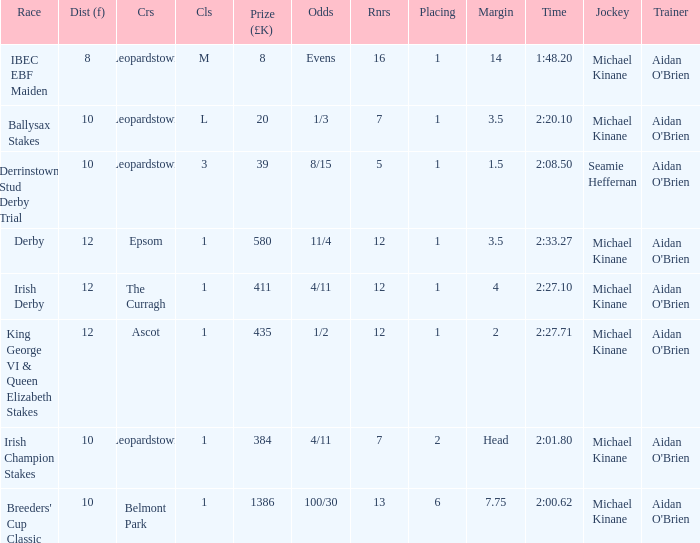Name the highest Dist (f) with Odds of 11/4 and a Placing larger than 1? None. 